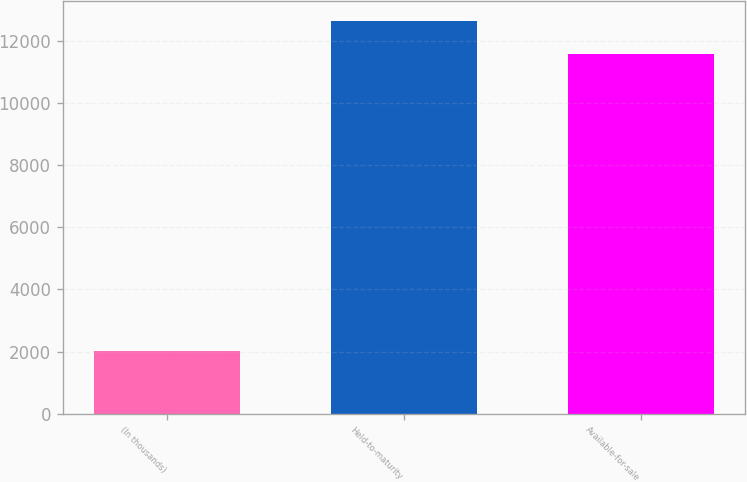Convert chart. <chart><loc_0><loc_0><loc_500><loc_500><bar_chart><fcel>(In thousands)<fcel>Held-to-maturity<fcel>Available-for-sale<nl><fcel>2016<fcel>12643.2<fcel>11582<nl></chart> 